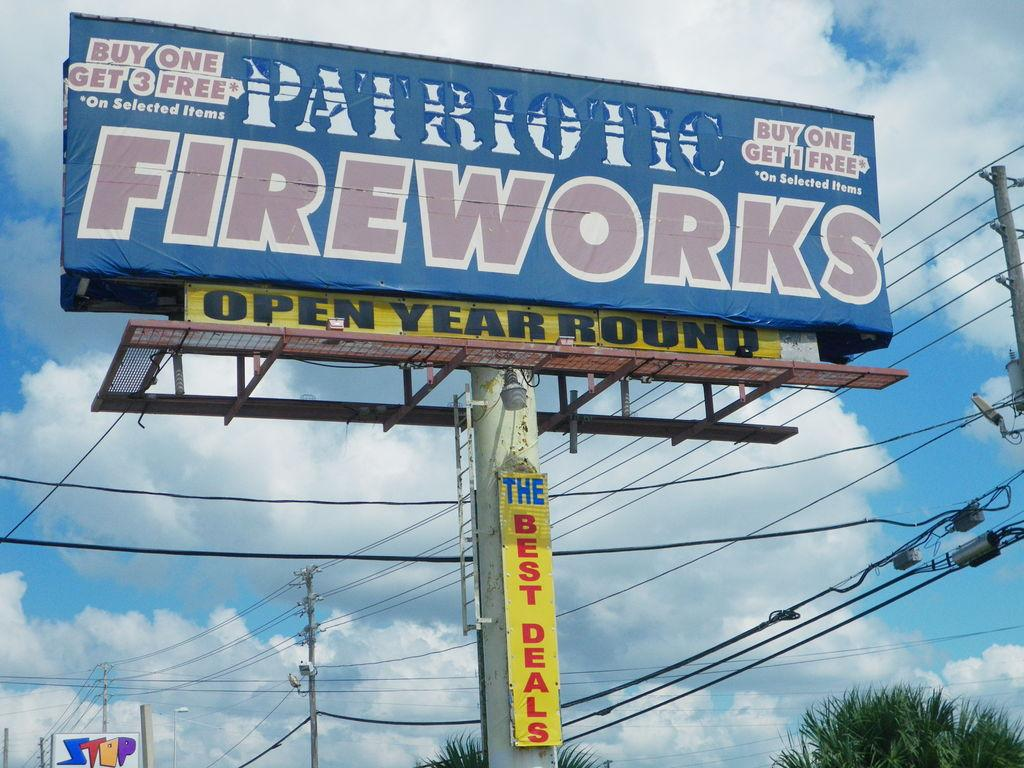<image>
Write a terse but informative summary of the picture. A billboard advertises Patriotic Fireworks and some special deals. 